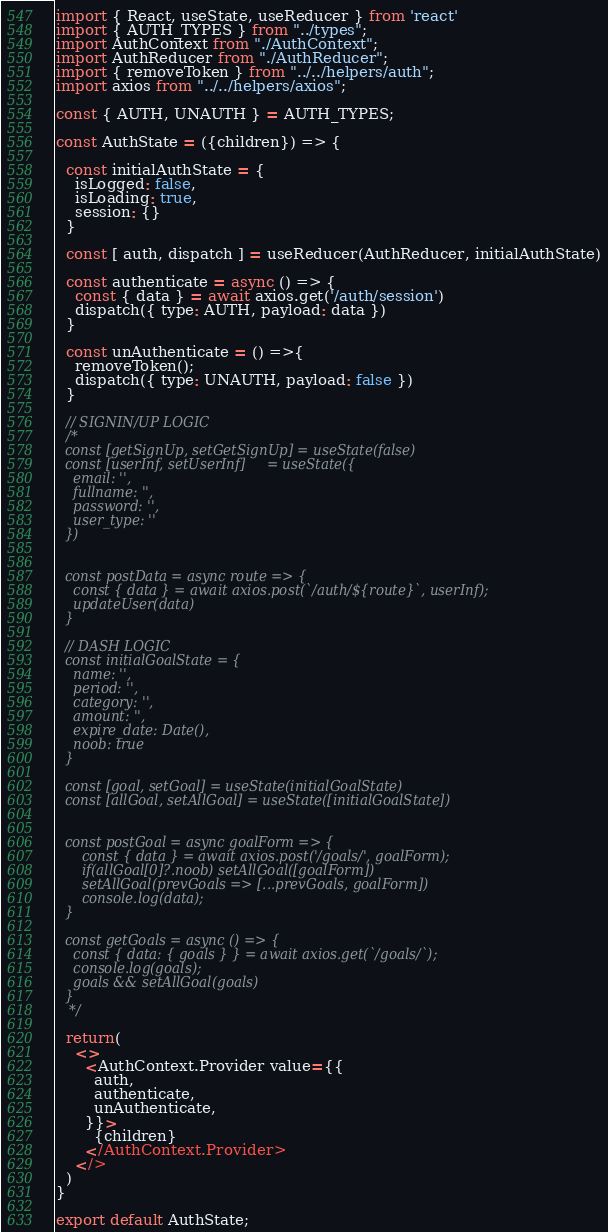<code> <loc_0><loc_0><loc_500><loc_500><_JavaScript_>import { React, useState, useReducer } from 'react'
import { AUTH_TYPES } from "../types";
import AuthContext from "./AuthContext";
import AuthReducer from "./AuthReducer";
import { removeToken } from "../../helpers/auth";
import axios from "../../helpers/axios";

const { AUTH, UNAUTH } = AUTH_TYPES;

const AuthState = ({children}) => {
  
  const initialAuthState = {
    isLogged: false,
    isLoading: true,
    session: {}
  }    

  const [ auth, dispatch ] = useReducer(AuthReducer, initialAuthState)
  
  const authenticate = async () => {
    const { data } = await axios.get('/auth/session')
    dispatch({ type: AUTH, payload: data })
  }

  const unAuthenticate = () =>{
    removeToken();
    dispatch({ type: UNAUTH, payload: false })
  }
  
  // SIGNIN/UP LOGIC 
  /* 
  const [getSignUp, setGetSignUp] = useState(false)
  const [userInf, setUserInf]     = useState({ 
    email: '',
    fullname: '',
    password: '',
    user_type: ''
  })
  

  const postData = async route => {
    const { data } = await axios.post(`/auth/${route}`, userInf);
    updateUser(data)
  }

  // DASH LOGIC 
  const initialGoalState = {
    name: '',
    period: '',
    category: '',
    amount: '',
    expire_date: Date(),
    noob: true
  }

  const [goal, setGoal] = useState(initialGoalState)
  const [allGoal, setAllGoal] = useState([initialGoalState])
  

  const postGoal = async goalForm => {
      const { data } = await axios.post('/goals/', goalForm);
      if(allGoal[0]?.noob) setAllGoal([goalForm])
      setAllGoal(prevGoals => [...prevGoals, goalForm])
      console.log(data);
  }

  const getGoals = async () => {
    const { data: { goals } } = await axios.get(`/goals/`);
    console.log(goals);
    goals && setAllGoal(goals)
  } 
   */
  
  return(
    <>
      <AuthContext.Provider value={{
        auth,
        authenticate,
        unAuthenticate,
      }}>
        {children}
      </AuthContext.Provider>
    </>
  )
}

export default AuthState;</code> 